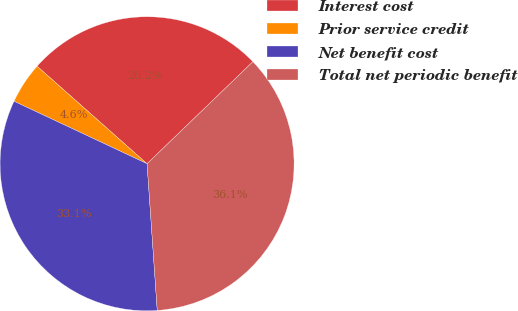Convert chart to OTSL. <chart><loc_0><loc_0><loc_500><loc_500><pie_chart><fcel>Interest cost<fcel>Prior service credit<fcel>Net benefit cost<fcel>Total net periodic benefit<nl><fcel>26.24%<fcel>4.56%<fcel>33.09%<fcel>36.11%<nl></chart> 